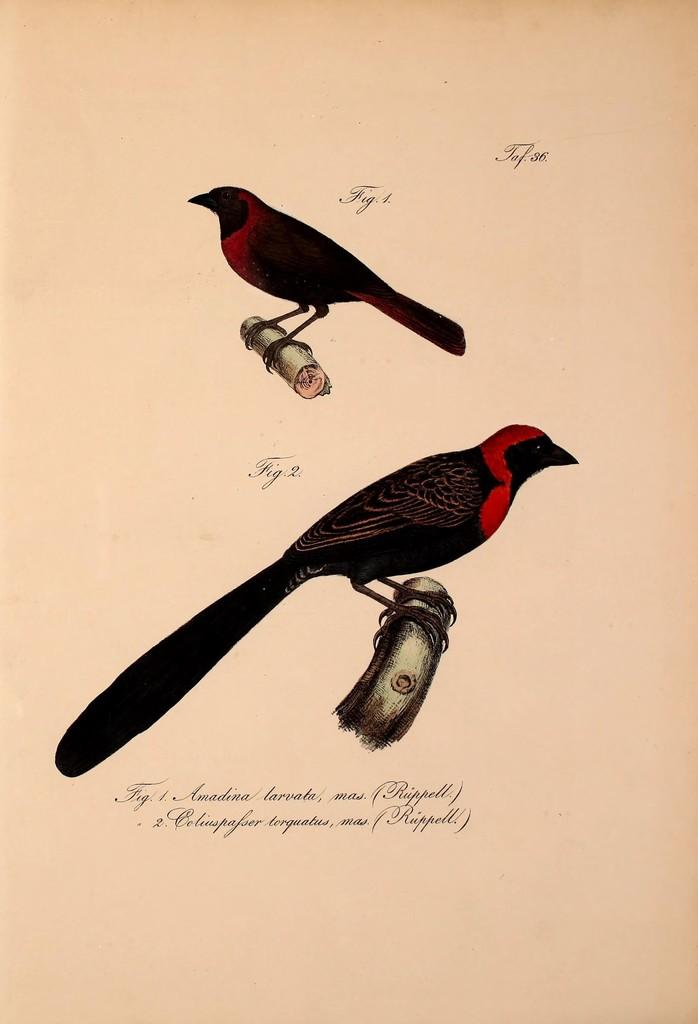What is featured on the poster in the image? Unfortunately, the facts provided do not specify what is on the poster. However, we can confirm that there is a poster in the image. What type of animals can be seen in the image? There are two birds on the wood in the image. Can you read any text in the image? Yes, there is some text visible in the image. What type of mint is growing near the birds in the image? There is no mint present in the image; it features a poster and two birds on wood. What is the birds using to hammer in the image? There is no hammer present in the image; the birds are simply perched on the wood. 